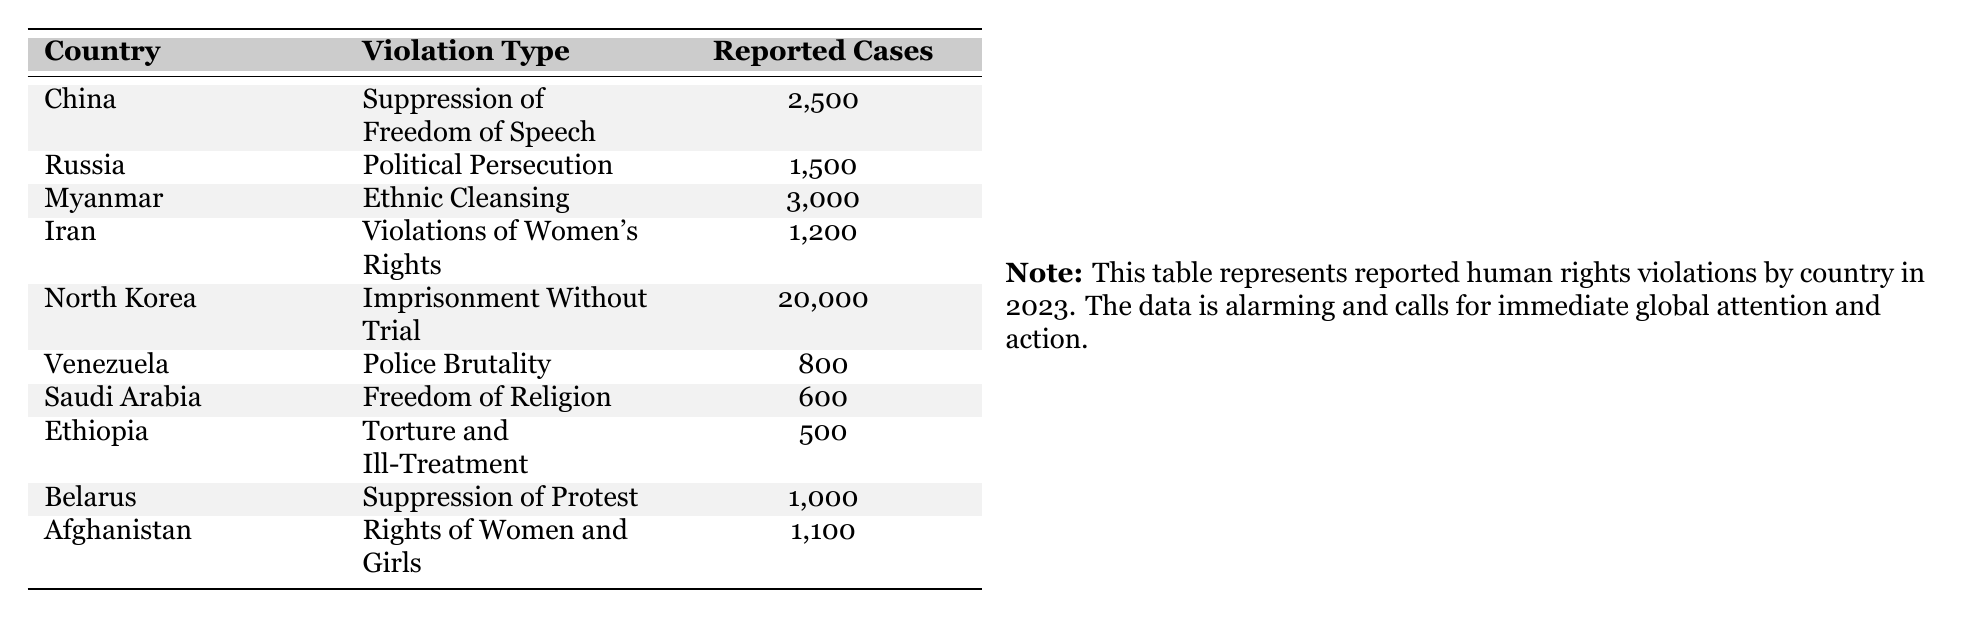What is the highest reported case of human rights violations? The table shows the reported cases of human rights violations by country. North Korea has the highest reported cases with 20,000.
Answer: 20,000 Which country has reported the least number of cases? Looking at the reported cases in the table, Ethiopia has the least reported cases of human rights violations, with a total of 500.
Answer: 500 How many total reported cases of human rights violations are listed in the table? To find the total, sum up all reported cases: 2,500 (China) + 1,500 (Russia) + 3,000 (Myanmar) + 1,200 (Iran) + 20,000 (North Korea) + 800 (Venezuela) + 600 (Saudi Arabia) + 500 (Ethiopia) + 1,000 (Belarus) + 1,100 (Afghanistan) = 32,200.
Answer: 32,200 Is the number of reported cases in Myanmar greater than that in Iran? By comparing the reported cases, Myanmar has 3,000 while Iran only has 1,200. Therefore, the statement is true.
Answer: Yes List the countries that have reported more than 1,000 cases of human rights violations. The countries with reported cases greater than 1,000, according to the table, are: China (2,500), Myanmar (3,000), North Korea (20,000), and Russia (1,500).
Answer: China, Myanmar, North Korea, Russia How many more reported cases are there in North Korea compared to Venezuela? Subtract the reported cases for Venezuela (800) from North Korea (20,000): 20,000 - 800 = 19,200.
Answer: 19,200 Are there more reported cases of Police Brutality than Violations of Women's Rights? Police Brutality in Venezuela has 800 cases, while Violations of Women's Rights in Iran has 1,200 cases. Since 1,200 is greater than 800, this statement is false.
Answer: No What is the average number of reported cases across all listed countries? To find the average, sum the reported cases (32,200) and divide by the number of countries (10): 32,200 / 10 = 3,220.
Answer: 3,220 Which violation type has the most reported cases? The table indicates that Imprisonment Without Trial in North Korea has the highest reported cases with 20,000.
Answer: Imprisonment Without Trial How many countries are represented in the table? The table lists a total of 10 different countries that have reported violations.
Answer: 10 